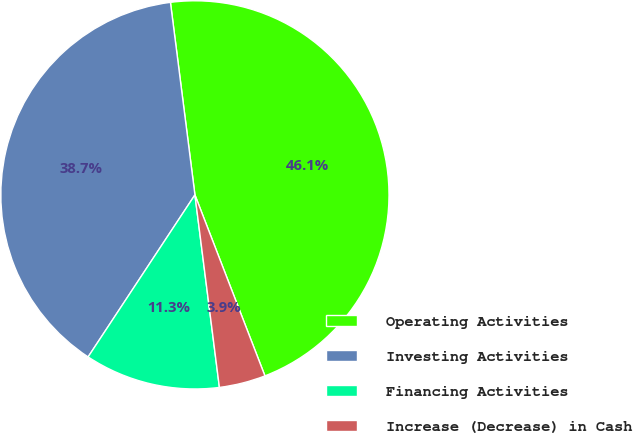<chart> <loc_0><loc_0><loc_500><loc_500><pie_chart><fcel>Operating Activities<fcel>Investing Activities<fcel>Financing Activities<fcel>Increase (Decrease) in Cash<nl><fcel>46.14%<fcel>38.71%<fcel>11.29%<fcel>3.86%<nl></chart> 